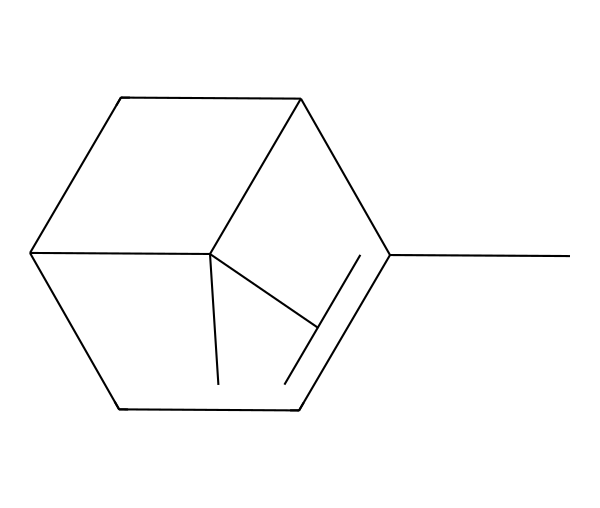How many carbon atoms are in pinene? By analyzing the SMILES representation, you can count the carbon atoms represented by the letter "C." In this molecule, there are a total of 10 carbon atoms.
Answer: 10 How many rings are present in the structure of pinene? The structure can be analyzed for cyclic components by looking for the numbers in the SMILES. The numbers indicate the start and end of rings; here there are two numbers indicating two rings.
Answer: 2 Is pinene a monocyclic or bicyclic compound? A bicyclic compound has two connected rings, which is what is indicated by the presence of two sets of numerical markers in the SMILES notation. Thus, pinene is classified as bicyclic.
Answer: bicyclic What is the chemical class of pinene? Pinene belongs to the class of compounds known as terpenes, which are defined by their structure and not heavily functionalized. The presence of carbon atoms and their arrangement fits this classification.
Answer: terpenes What type of functional groups are present in pinene? Upon examining the SMILES, pinene does not display any functional groups like alcohols or acids; thus, it is primarily comprised of hydrocarbon components.
Answer: none Which part of pinene contributes to its characteristic scent? The structure of pinene, specifically the arrangement of its carbon atoms in the rings, is crucial in forming its characteristic aroma associated with pine and rosemary.
Answer: rings 